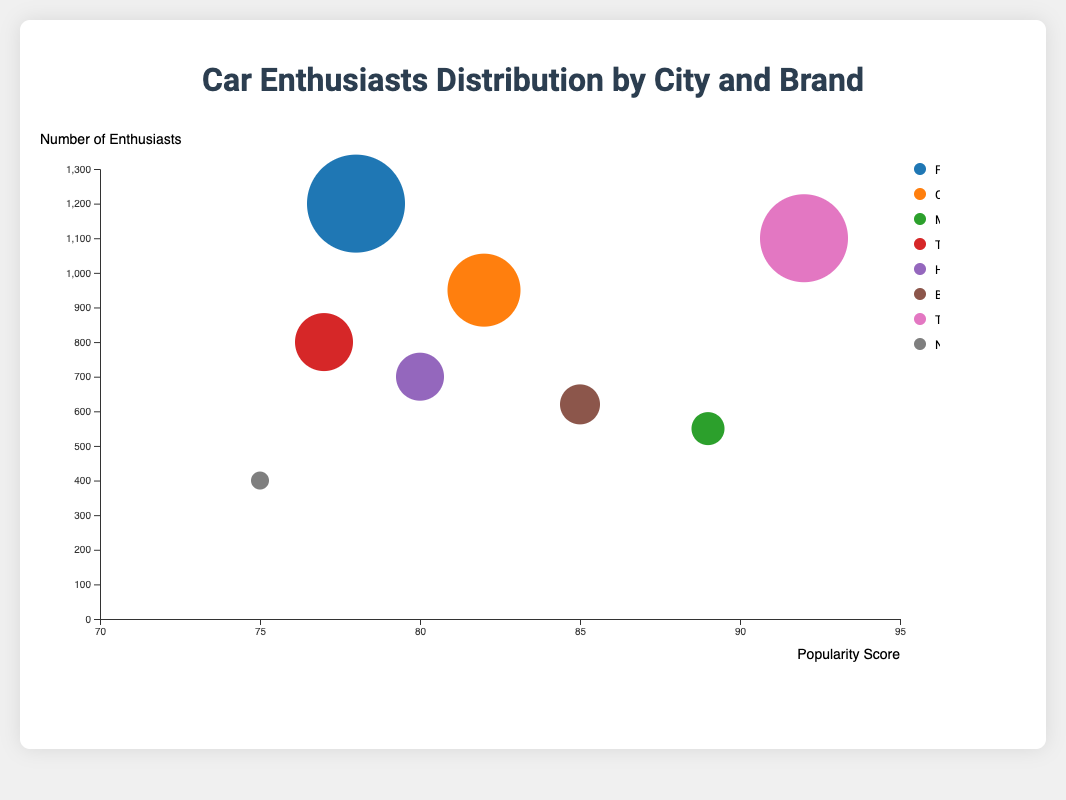What is the most popular car brand in San Francisco? By referring to the chart and looking at the data point located in San Francisco, you can identify that the color of the bubble corresponding to San Francisco represents Tesla with a popularity score of 92.
Answer: Tesla Which city has the highest number of car enthusiasts? Look at the y-axis (number of enthusiasts) and find the highest data point on the plot. The highest number of enthusiasts is represented by the largest bubble at the highest y-position, which corresponds to Los Angeles with 1200 enthusiasts.
Answer: Los Angeles What is the popularity score of Mercedes-Benz in Miami? Locate the bubble corresponding to Miami and refer to the tooltip or the position on the x-axis, which indicates the popularity score. The bubble for Miami is associated with Mercedes-Benz and has a popularity score of 89.
Answer: 89 Which city has the highest popularity score for car enthusiasts, and what brand is it? By examining the x-axis, identify the data point farthest to the right. The bubble with the highest popularity score is for San Francisco with a score of 92, and the brand is Tesla.
Answer: San Francisco, Tesla Compare the number of car enthusiasts in Houston and Dallas. Which city has more? Locate both Houston and Dallas on the y-axis (number of enthusiasts). Houston has 800 enthusiasts, while Dallas has 400. Therefore, Houston has more car enthusiasts.
Answer: Houston How does the popularity score of Chevrolet in New York compare to the popularity score of BMW in Atlanta? Find the bubbles for New York (Chevrolet) and Atlanta (BMW) on the x-axis (popularity score). New York has a popularity score of 82 while Atlanta has a score of 85. Atlanta's score is higher.
Answer: Atlanta has a higher score Which car brand has the least number of enthusiasts, and in which city is it found? By checking the smallest bubbles representing the number of enthusiasts, the smallest is Dallas (Nissan) with 400 enthusiasts.
Answer: Nissan, Dallas Which city has the second highest number of car enthusiasts? Identify the bubble with the second highest y-value. The second highest number of enthusiasts is in San Francisco with 1100 enthusiasts.
Answer: San Francisco What is the total number of car enthusiasts in Los Angeles, New York, and Miami combined? Add the number of enthusiasts in these three cities: Los Angeles (1200) + New York (950) + Miami (550) = 2700.
Answer: 2700 Compare the popularity scores and number of enthusiasts for Honda in Chicago and Toyota in Houston. Which city has a higher score and more enthusiasts? Chicago (Honda) has a popularity score of 80 and 700 enthusiasts. Houston (Toyota) has a score of 77 and 800 enthusiasts. Houston has more enthusiasts, but Chicago has a higher popularity score.
Answer: Houston has more enthusiasts, Chicago has a higher score 